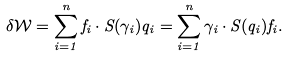<formula> <loc_0><loc_0><loc_500><loc_500>\delta \mathcal { W } = \sum _ { i = 1 } ^ { n } f _ { i } \cdot S ( \gamma _ { i } ) q _ { i } = \sum _ { i = 1 } ^ { n } \gamma _ { i } \cdot S ( q _ { i } ) f _ { i } .</formula> 